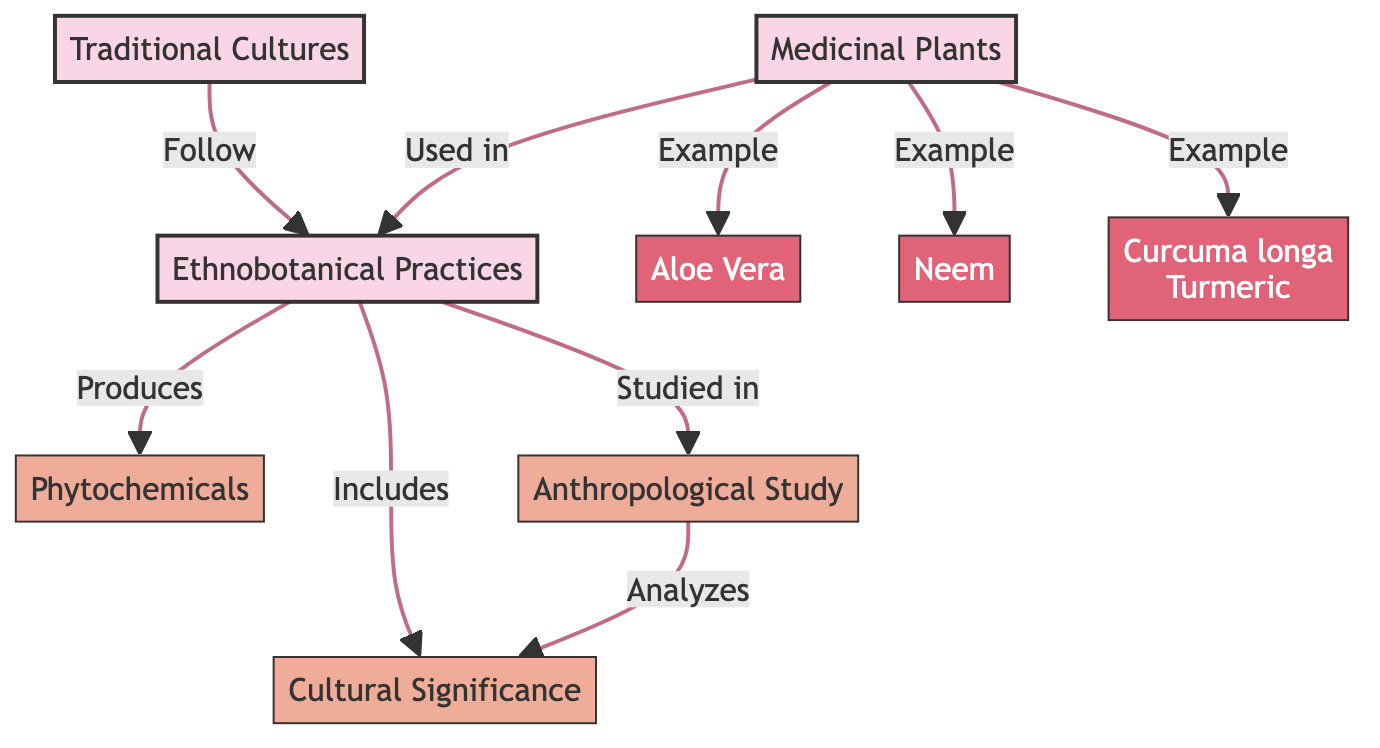What are the main categories represented in this diagram? The diagram presents three main categories: Medicinal Plants, Traditional Cultures, and Ethnobotanical Practices, each positioned as a main node and visually distinguished.
Answer: Medicinal Plants, Traditional Cultures, Ethnobotanical Practices How many examples of medicinal plants are listed in the diagram? The diagram specifies three examples of medicinal plants labeled directly under the "Medicinal Plants" node: Aloe Vera, Neem, and Curcuma longa (Turmeric), which are plant nodes connected to the main category.
Answer: 3 What relationship exists between Ethnobotanical Practices and Phytochemicals? Ethnobotanical Practices produces Phytochemicals, indicated by a directional arrow in the diagram illustrating the flow from Ethnobotanical Practices to Phytochemicals.
Answer: Produces How does Cultural Significance relate to Ethnobotanical Practices? Cultural Significance is shown as a direct sub-node of Ethnobotanical Practices, indicating that it is an integral part of the practices involved in this context.
Answer: Includes What is studied within Ethnobotanical Practices according to the diagram? The diagram explicitly states that Ethnobotanical Practices is studied in the context of the Anthropological Study, indicating a research connection depicted by a directional arrow.
Answer: Anthropological Study How are medicinal plants characterized within traditional cultures in this diagram? The medicinal plants are characterized as being directly used in Ethnobotanical Practices, showing their role within the context of traditional cultures and emphasizing their practical application.
Answer: Used in Which plant is represented as an example of medicinal plants in this diagram? Aloe Vera, Neem, and Curcuma longa (Turmeric) are all examples identified within the Medicinal Plants category, directly labeled and illustrated in the diagram.
Answer: Aloe Vera What does the interaction between Anthropological Study and Cultural Significance indicate? The diagram indicates that the Anthropological Study analyzes Cultural Significance, showing a research-focused relationship that connects cultural aspects to the scientific study of these practices.
Answer: Analyzes How many connections are there between Medicinal Plants and Ethnobotanical Practices? There is one primary connection showing that Medicinal Plants are used in Ethnobotanical Practices, reinforcing the plant's role in traditional medicine.
Answer: 1 